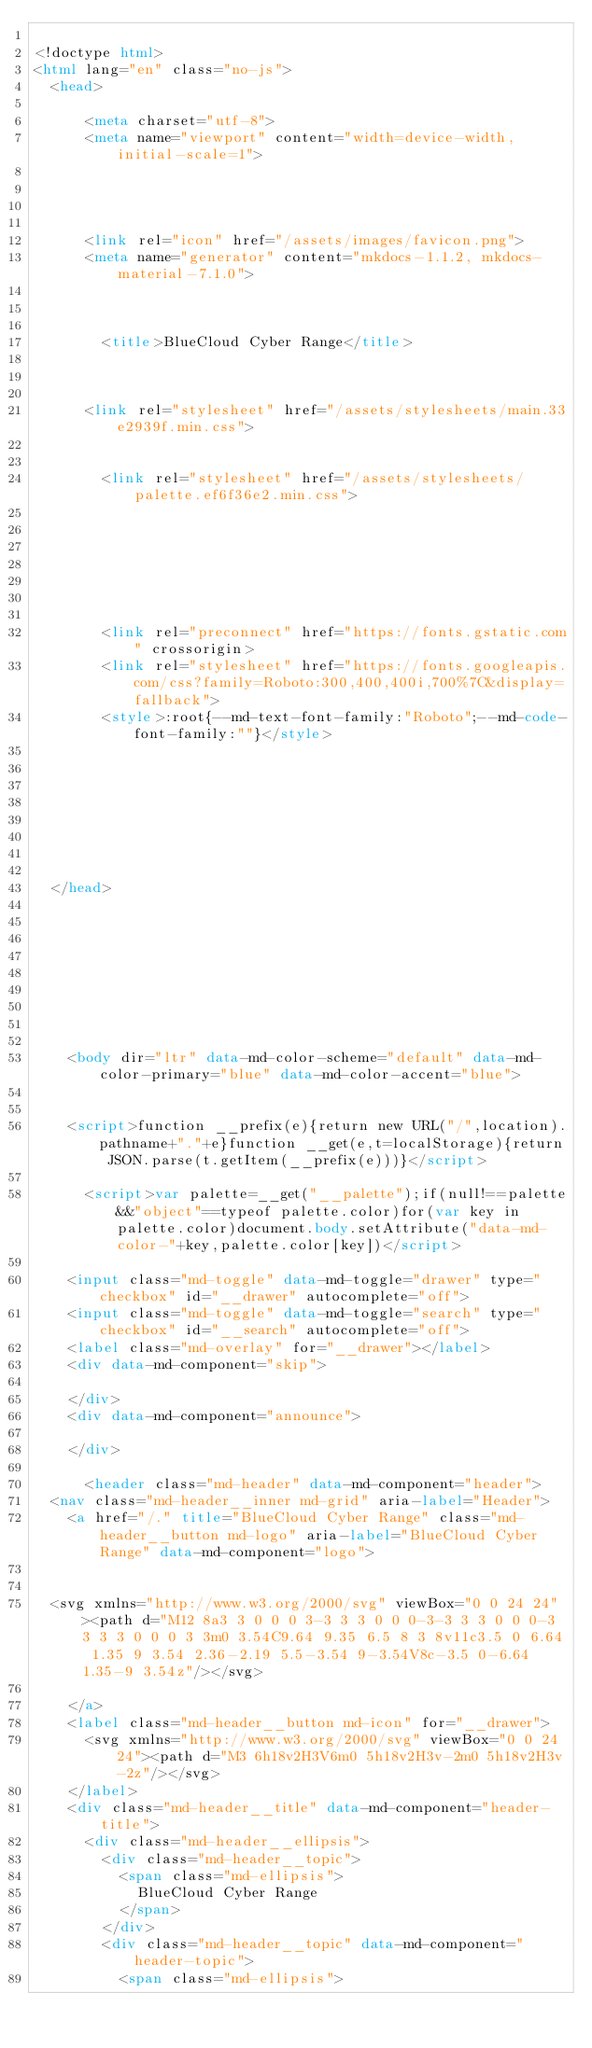Convert code to text. <code><loc_0><loc_0><loc_500><loc_500><_HTML_>
<!doctype html>
<html lang="en" class="no-js">
  <head>
    
      <meta charset="utf-8">
      <meta name="viewport" content="width=device-width,initial-scale=1">
      
      
      
      
      <link rel="icon" href="/assets/images/favicon.png">
      <meta name="generator" content="mkdocs-1.1.2, mkdocs-material-7.1.0">
    
    
      
        <title>BlueCloud Cyber Range</title>
      
    
    
      <link rel="stylesheet" href="/assets/stylesheets/main.33e2939f.min.css">
      
        
        <link rel="stylesheet" href="/assets/stylesheets/palette.ef6f36e2.min.css">
        
      
    
    
    
      
        
        <link rel="preconnect" href="https://fonts.gstatic.com" crossorigin>
        <link rel="stylesheet" href="https://fonts.googleapis.com/css?family=Roboto:300,400,400i,700%7C&display=fallback">
        <style>:root{--md-text-font-family:"Roboto";--md-code-font-family:""}</style>
      
    
    
    
    
      
    
    
  </head>
  
  
    
    
      
    
    
    
    
    <body dir="ltr" data-md-color-scheme="default" data-md-color-primary="blue" data-md-color-accent="blue">
  
    
    <script>function __prefix(e){return new URL("/",location).pathname+"."+e}function __get(e,t=localStorage){return JSON.parse(t.getItem(__prefix(e)))}</script>
    
      <script>var palette=__get("__palette");if(null!==palette&&"object"==typeof palette.color)for(var key in palette.color)document.body.setAttribute("data-md-color-"+key,palette.color[key])</script>
    
    <input class="md-toggle" data-md-toggle="drawer" type="checkbox" id="__drawer" autocomplete="off">
    <input class="md-toggle" data-md-toggle="search" type="checkbox" id="__search" autocomplete="off">
    <label class="md-overlay" for="__drawer"></label>
    <div data-md-component="skip">
      
    </div>
    <div data-md-component="announce">
      
    </div>
    
      <header class="md-header" data-md-component="header">
  <nav class="md-header__inner md-grid" aria-label="Header">
    <a href="/." title="BlueCloud Cyber Range" class="md-header__button md-logo" aria-label="BlueCloud Cyber Range" data-md-component="logo">
      
  
  <svg xmlns="http://www.w3.org/2000/svg" viewBox="0 0 24 24"><path d="M12 8a3 3 0 0 0 3-3 3 3 0 0 0-3-3 3 3 0 0 0-3 3 3 3 0 0 0 3 3m0 3.54C9.64 9.35 6.5 8 3 8v11c3.5 0 6.64 1.35 9 3.54 2.36-2.19 5.5-3.54 9-3.54V8c-3.5 0-6.64 1.35-9 3.54z"/></svg>

    </a>
    <label class="md-header__button md-icon" for="__drawer">
      <svg xmlns="http://www.w3.org/2000/svg" viewBox="0 0 24 24"><path d="M3 6h18v2H3V6m0 5h18v2H3v-2m0 5h18v2H3v-2z"/></svg>
    </label>
    <div class="md-header__title" data-md-component="header-title">
      <div class="md-header__ellipsis">
        <div class="md-header__topic">
          <span class="md-ellipsis">
            BlueCloud Cyber Range
          </span>
        </div>
        <div class="md-header__topic" data-md-component="header-topic">
          <span class="md-ellipsis">
            
              </code> 